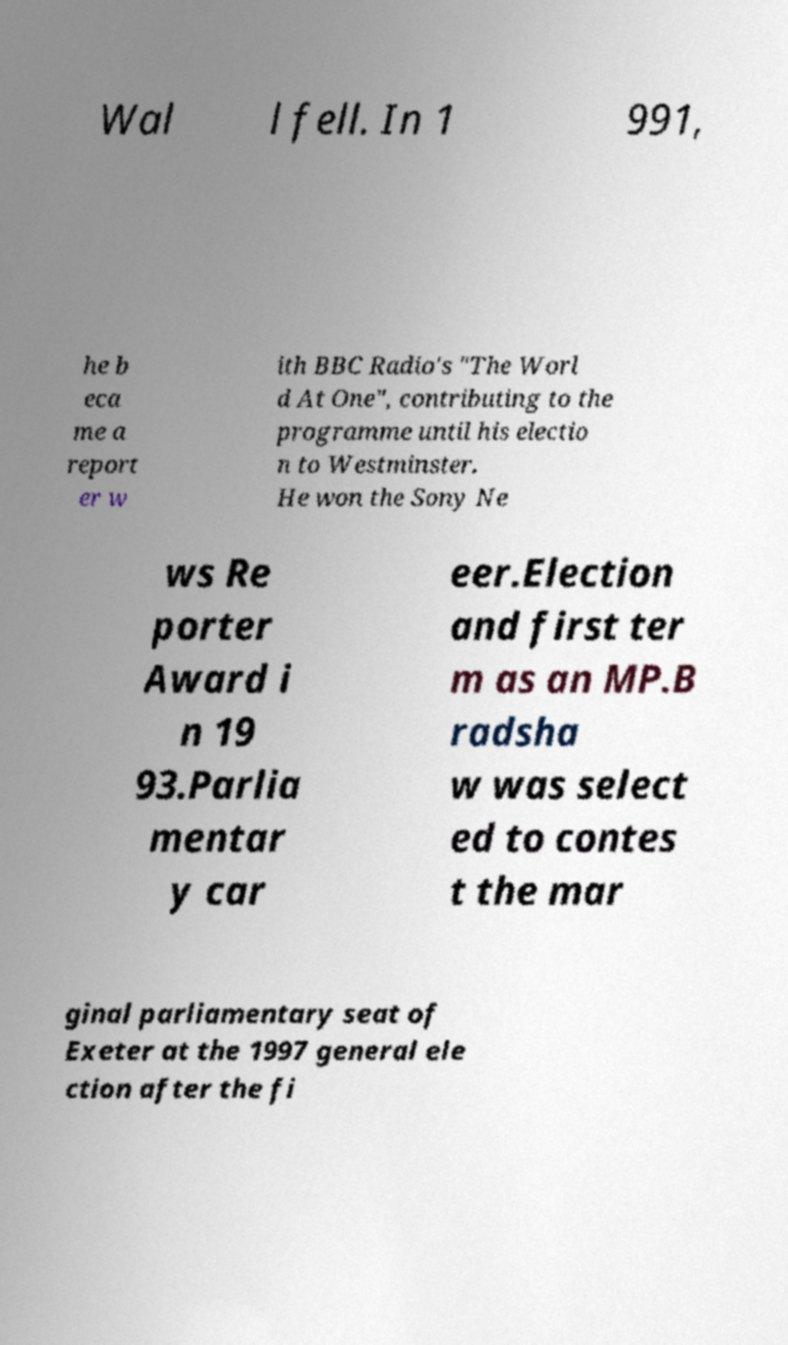Please read and relay the text visible in this image. What does it say? Wal l fell. In 1 991, he b eca me a report er w ith BBC Radio's "The Worl d At One", contributing to the programme until his electio n to Westminster. He won the Sony Ne ws Re porter Award i n 19 93.Parlia mentar y car eer.Election and first ter m as an MP.B radsha w was select ed to contes t the mar ginal parliamentary seat of Exeter at the 1997 general ele ction after the fi 